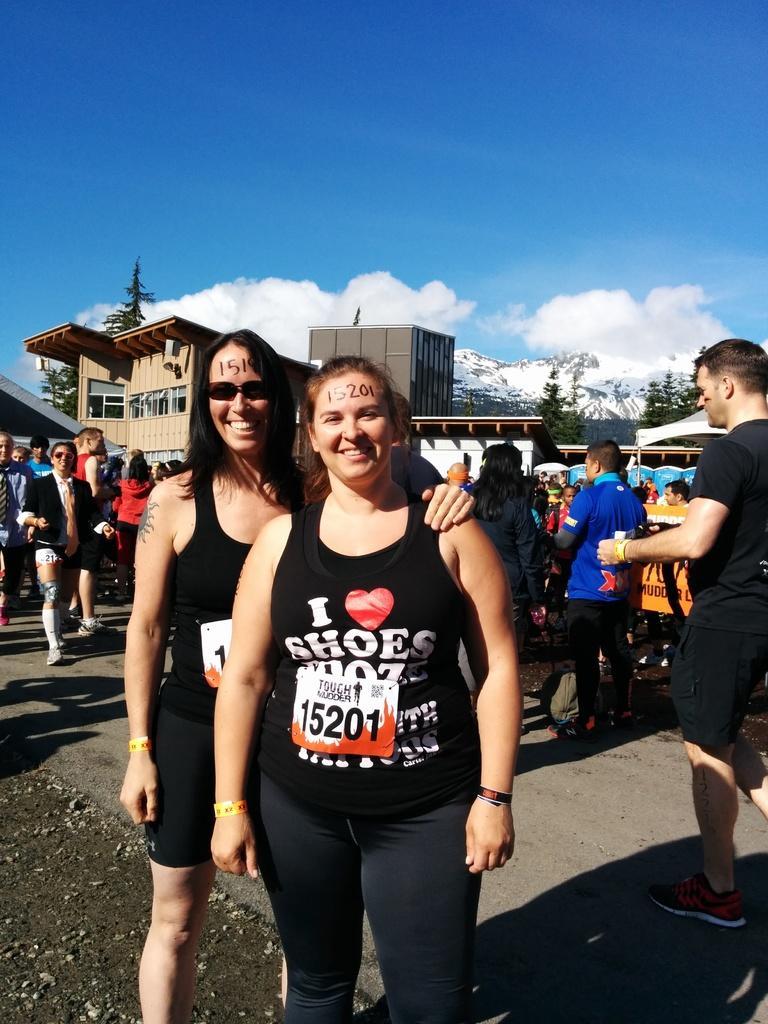Describe this image in one or two sentences. In the image we can see there are women standing and they are smiling. Behind there are other people standing and there are trees and there are buildings. There are mountains which are covered with snow. 